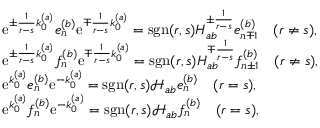Convert formula to latex. <formula><loc_0><loc_0><loc_500><loc_500>\begin{array} { r l } & { e ^ { \pm \frac { 1 } { r - s } k _ { 0 } ^ { ( a ) } } e _ { n } ^ { ( b ) } e ^ { \mp \frac { 1 } { r - s } k _ { 0 } ^ { ( a ) } } = s g n ( r , s ) { H } _ { a b } ^ { \pm \frac { 1 } { r - s } } e _ { n \mp 1 } ^ { ( b ) } \quad ( r \neq s ) , } \\ & { e ^ { \pm \frac { 1 } { r - s } k _ { 0 } ^ { ( a ) } } f _ { n } ^ { ( b ) } e ^ { \mp \frac { 1 } { r - s } k _ { 0 } ^ { ( a ) } } = s g n ( r , s ) { H } _ { a b } ^ { \mp \frac { 1 } { r - s } } f _ { n \pm 1 } ^ { ( b ) } \quad ( r \neq s ) , } \\ & { e ^ { k _ { 0 } ^ { ( a ) } } e _ { n } ^ { ( b ) } e ^ { - k _ { 0 } ^ { ( a ) } } = s g n ( r , s ) \mathcal { H } _ { a b } e _ { n } ^ { ( b ) } \quad ( r = s ) , } \\ & { e ^ { k _ { 0 } ^ { ( a ) } } f _ { n } ^ { ( b ) } e ^ { - k _ { 0 } ^ { ( a ) } } = s g n ( r , s ) \mathcal { H } _ { a b } f _ { n } ^ { ( b ) } \quad ( r = s ) , } \end{array}</formula> 